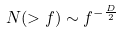Convert formula to latex. <formula><loc_0><loc_0><loc_500><loc_500>N ( > f ) \sim f ^ { - \frac { D } { 2 } }</formula> 